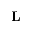<formula> <loc_0><loc_0><loc_500><loc_500>L</formula> 